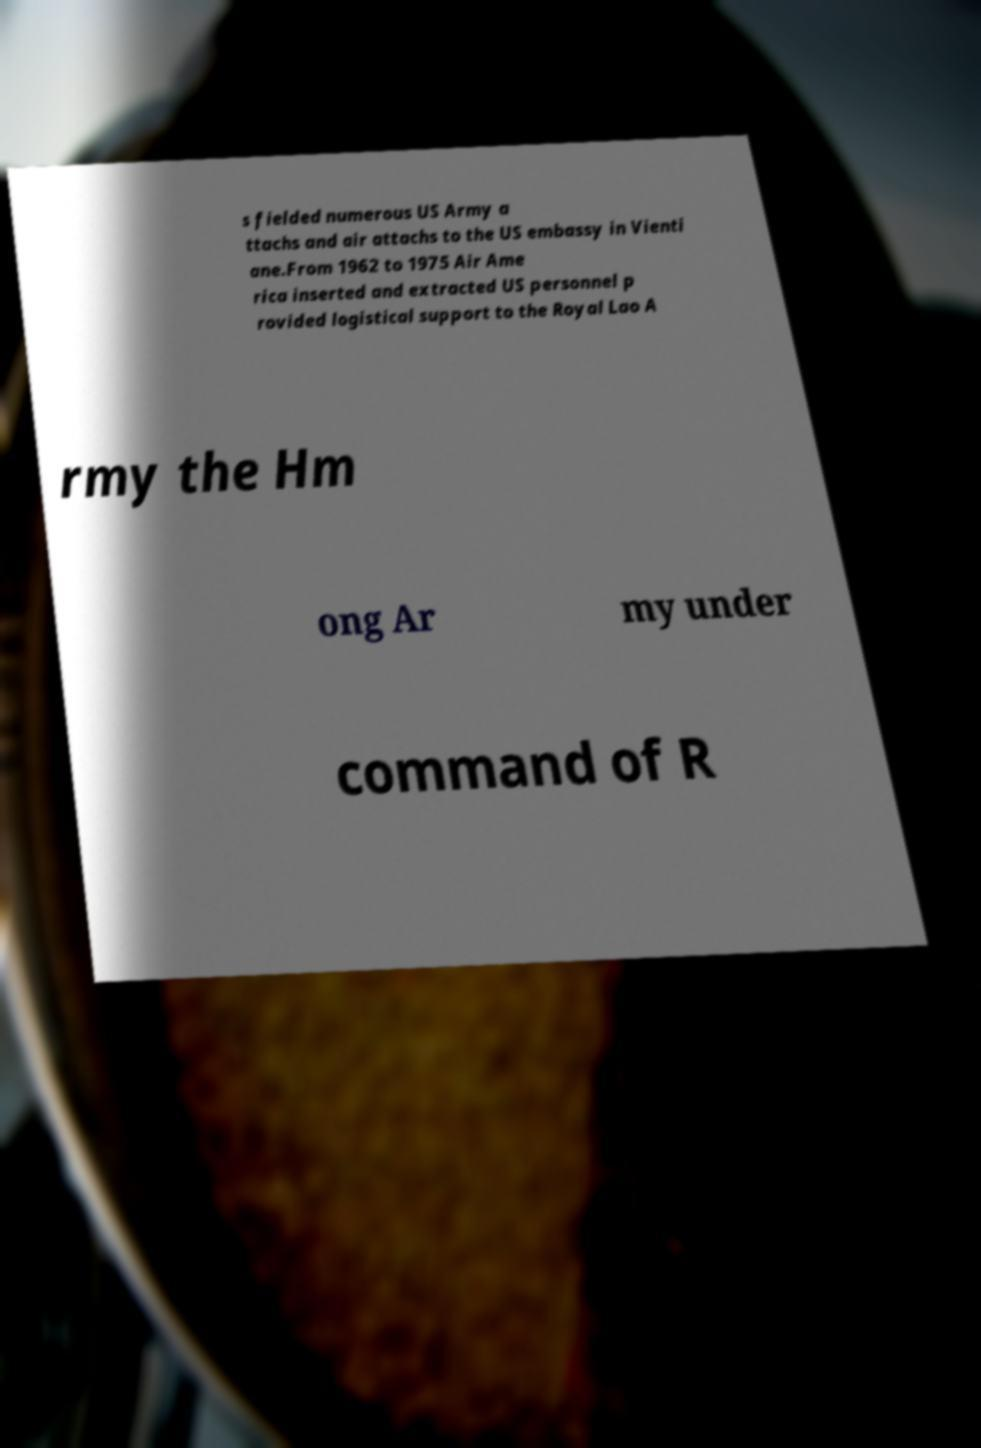Can you accurately transcribe the text from the provided image for me? s fielded numerous US Army a ttachs and air attachs to the US embassy in Vienti ane.From 1962 to 1975 Air Ame rica inserted and extracted US personnel p rovided logistical support to the Royal Lao A rmy the Hm ong Ar my under command of R 